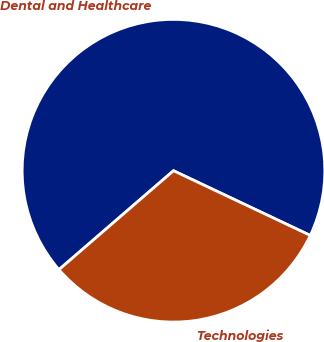Convert chart. <chart><loc_0><loc_0><loc_500><loc_500><pie_chart><fcel>Dental and Healthcare<fcel>Technologies<nl><fcel>68.37%<fcel>31.63%<nl></chart> 